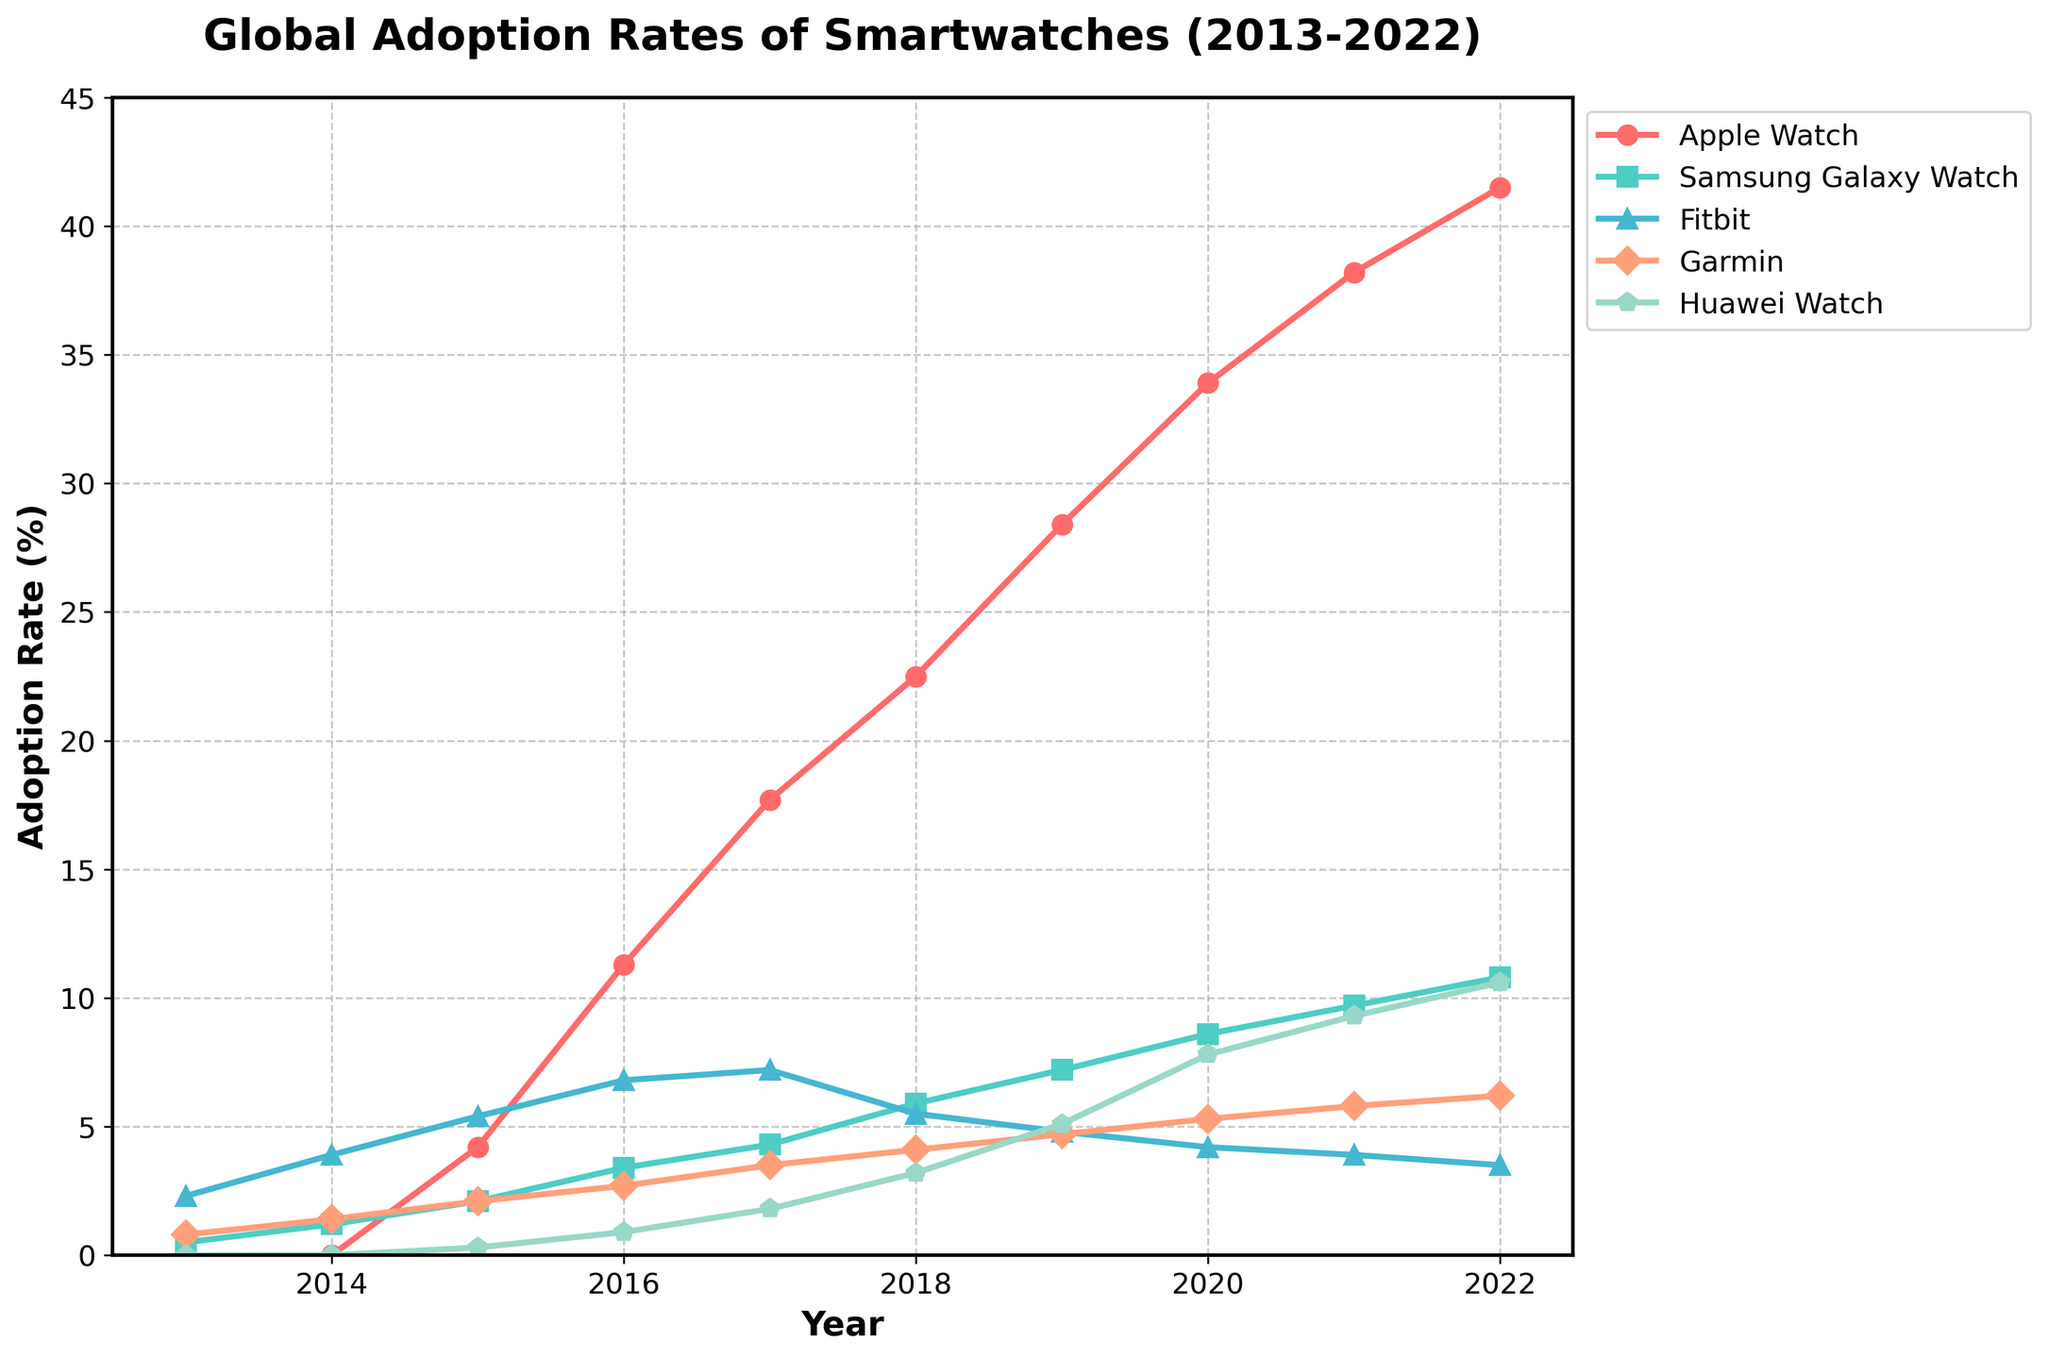What was the adoption rate of Apple Watch in 2015? Check the graph for the line representing Apple Watch in 2015 and read off the value.
Answer: 4.2% Which brand had the highest adoption rate in 2022? Look for the line that reaches the highest point in the year 2022.
Answer: Apple Watch Between 2016 and 2018, which brand showed the steepest increase in adoption rate? Compare the slopes of the lines for each brand between 2016 and 2018. The steepest slope indicates the steepest increase.
Answer: Apple Watch By how much did the adoption rate of Huawei Watch increase from 2016 to 2020? Subtract the adoption rate of Huawei Watch in 2016 from its rate in 2020: 7.8 (2020) - 0.9 (2016).
Answer: 6.9% What is the difference in adoption rates between Fitbit and Garmin in 2018? Find the values for Fitbit and Garmin in 2018 and subtract Garmin's value from Fitbit's: 5.5 (Fitbit) - 4.1 (Garmin).
Answer: 1.4% Which brand showed the most consistent increase in adoption rate across the decade? Evaluate each brand’s line for a smooth, consistent upward trend throughout the entire period from 2013 to 2022.
Answer: Apple Watch In what year did Samsung Galaxy Watch surpass Fitbit in adoption rates? Identify the year when the Samsung Galaxy Watch line crosses above the Fitbit line.
Answer: 2019 What's the average adoption rate of Garmin from 2014 to 2018? Sum Garmin's adoption rates from 2014 to 2018 and divide by the number of years: (1.4 + 2.1 + 2.7 + 3.5 + 4.1)/5.
Answer: 2.76% Which two brands had adoption rates closest to each other in 2017? Compare the adoption rates of all brands in 2017 and find the pair with the smallest difference.
Answer: Fitbit and Garmin Which brand had the lowest adoption rate in 2014? Locate the lowest point among the lines for all brands in the year 2014.
Answer: Apple Watch (since it was not yet released) 